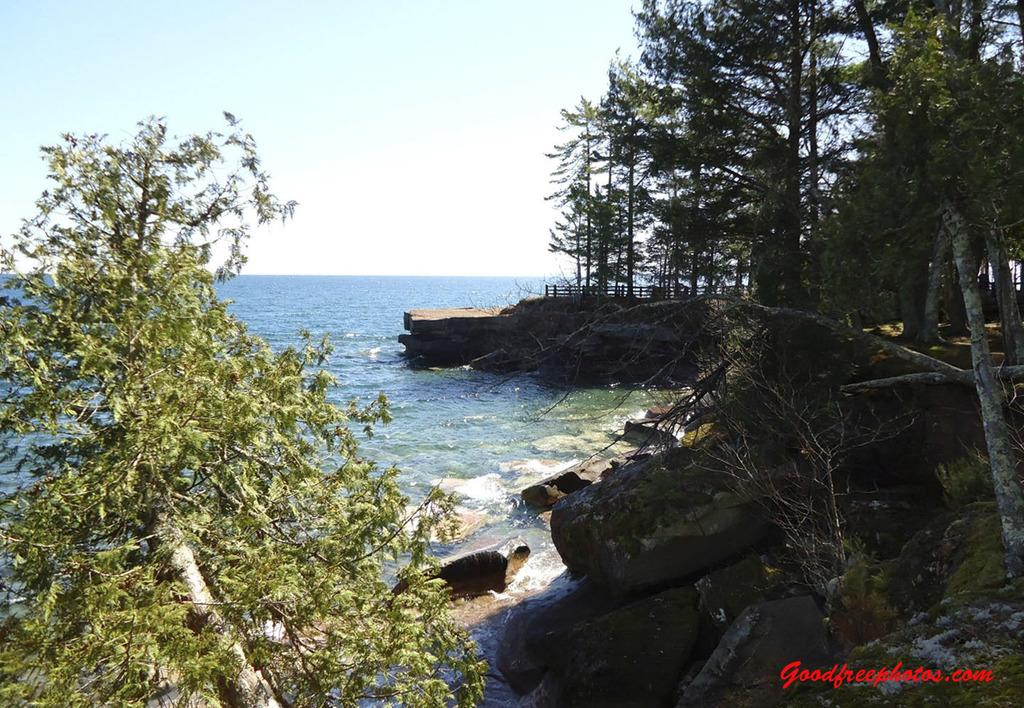What can be seen in the foreground of the picture? In the foreground of the picture, there are rocks, grass, plants, and trees. Are there any trees on the right side of the picture? Yes, there are trees on the right side of the picture. What is located on the right side of the picture? In addition to trees, there is a dock on the right side of the picture. What is visible on the left side of the picture? There is water on the left side of the picture. What is the condition of the sky in the image? The sky is clear, and it is sunny. What type of hair can be seen on the partner in the image? There is no partner present in the image, and therefore no hair can be observed. How many stitches are visible on the sweater in the image? There is no sweater present in the image, and therefore no stitches can be counted. 